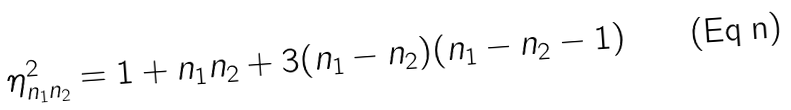Convert formula to latex. <formula><loc_0><loc_0><loc_500><loc_500>\eta ^ { 2 } _ { n _ { 1 } n _ { 2 } } = 1 + n _ { 1 } n _ { 2 } + 3 ( n _ { 1 } - n _ { 2 } ) ( n _ { 1 } - n _ { 2 } - 1 )</formula> 